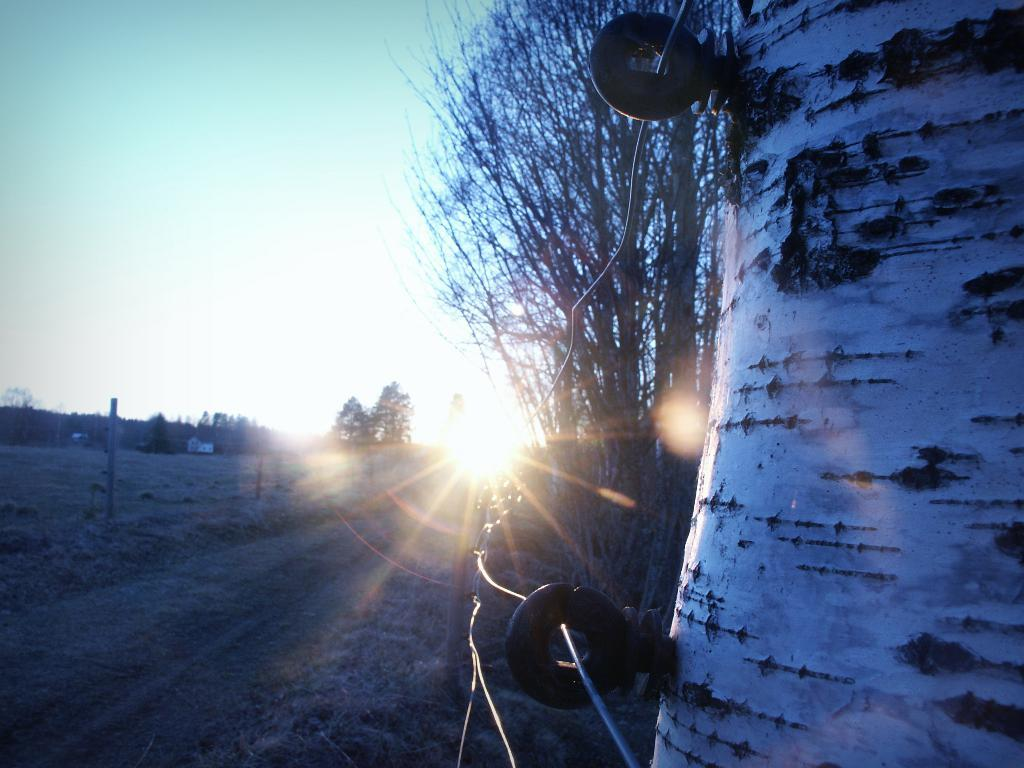What can be seen on the right side of the image? There is a tree trunk on the right side of the image. What type of structure is present in the image? There is a fence in the image. What is the condition of the trees in the image? Dry trees are present in the image. What is the source of light in the image? Sun rays are visible in the image. What type of pathway is visible in the image? There is a road in the image. What is the ground like in the image? The ground is visible in the image. How would you describe the sky in the background? The sky in the background is plain. Can you tell me how many rods are used to create the fence in the image? There is no mention of rods in the image; the fence is described as a single structure. Is there a list of items hanging from the tree trunk in the image? There is no list or any hanging items mentioned in the image; only the tree trunk and other elements are described. 